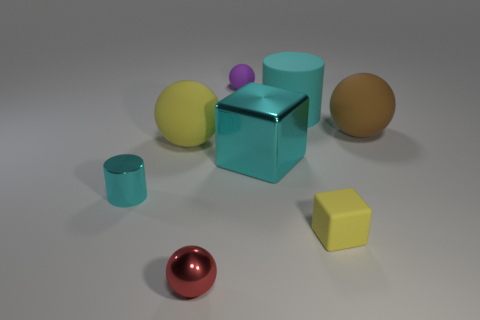How many yellow things are either tiny metallic objects or spheres?
Your answer should be compact. 1. There is a metallic cylinder that is the same color as the big matte cylinder; what size is it?
Offer a very short reply. Small. There is a large brown ball; how many matte balls are in front of it?
Your answer should be compact. 1. There is a shiny thing that is right of the object behind the cyan cylinder that is right of the purple object; what size is it?
Offer a terse response. Large. Are there any metal cylinders on the right side of the large ball that is on the right side of the small rubber thing right of the large shiny block?
Offer a terse response. No. Is the number of matte things greater than the number of small yellow things?
Keep it short and to the point. Yes. What color is the matte sphere that is right of the matte cube?
Make the answer very short. Brown. Is the number of blocks right of the small red metallic ball greater than the number of blue blocks?
Provide a short and direct response. Yes. Is the cyan block made of the same material as the tiny cyan cylinder?
Ensure brevity in your answer.  Yes. What number of other objects are there of the same shape as the big brown rubber object?
Ensure brevity in your answer.  3. 